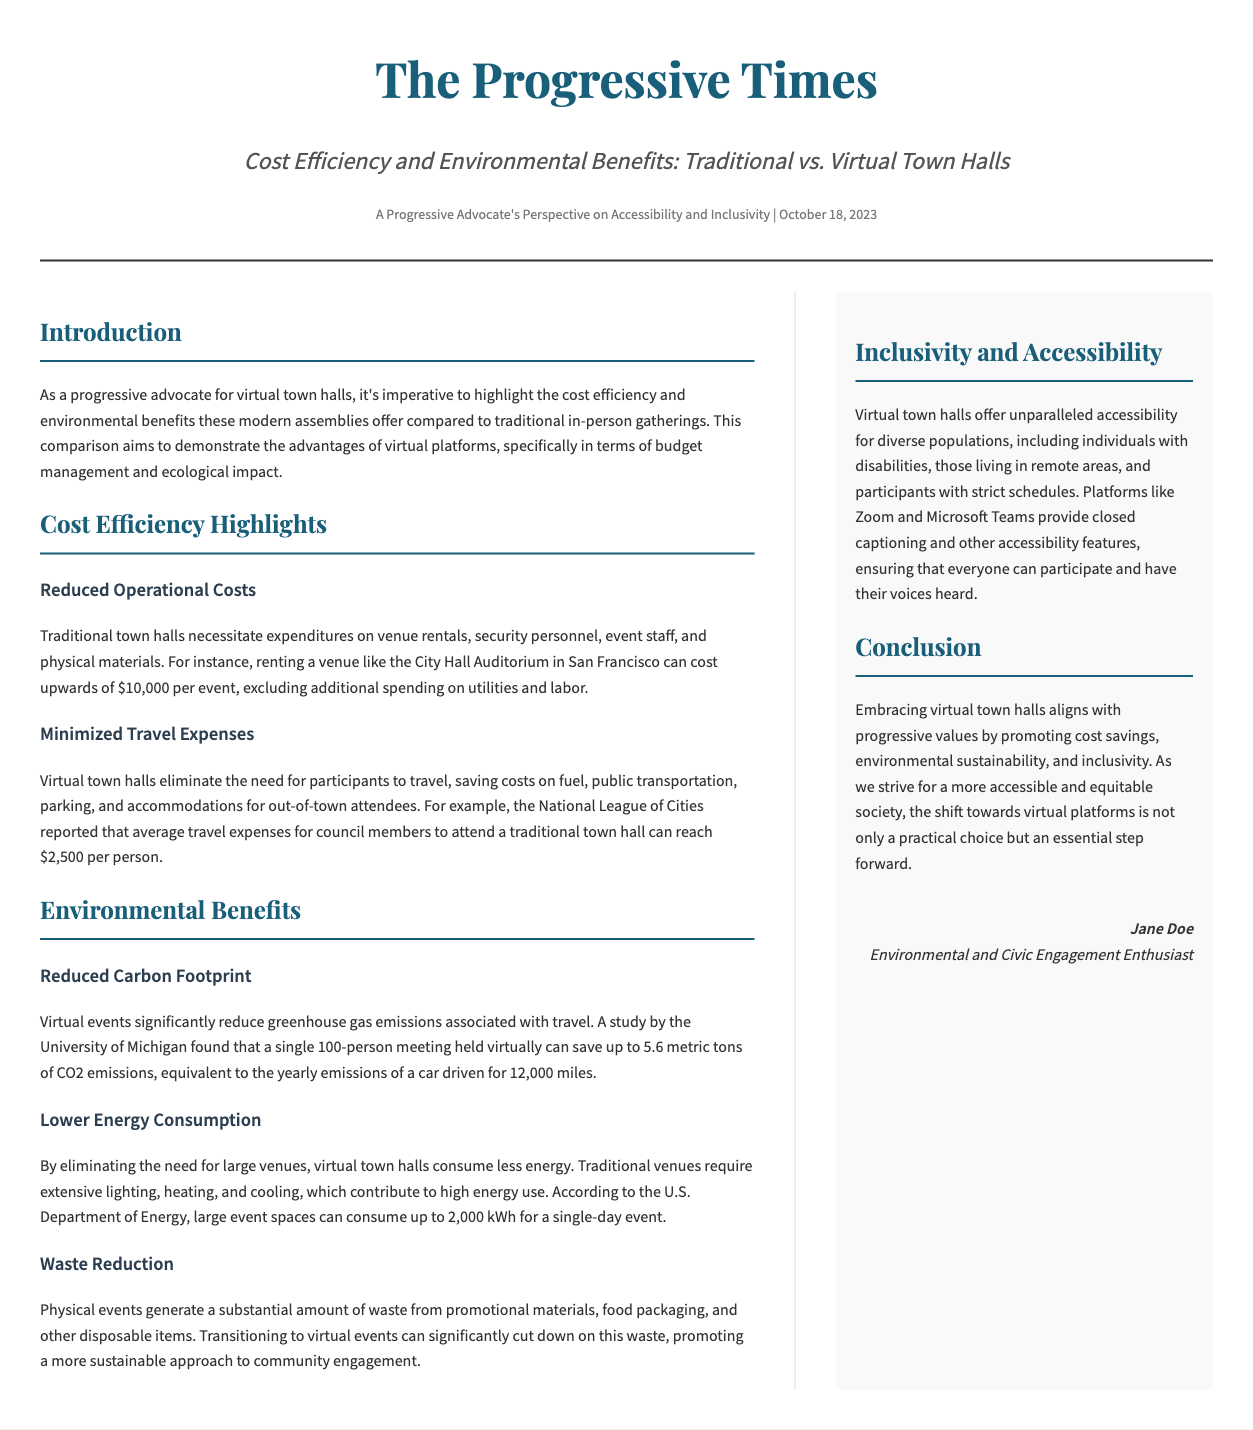what is the subtitle of the article? The subtitle provides insight into the article’s focus, which is "Cost Efficiency and Environmental Benefits: Traditional vs. Virtual Town Halls."
Answer: Cost Efficiency and Environmental Benefits: Traditional vs. Virtual Town Halls how much can renting the City Hall Auditorium cost? The document specifies that renting the venue can cost upwards of $10,000 per event.
Answer: $10,000 what is the average travel expense reported by the National League of Cities? This expense pertains to the cost for council members attending a traditional town hall, reported to be $2,500 per person.
Answer: $2,500 how much CO2 emissions can a virtual 100-person meeting save? The study mentioned indicates that a virtual meeting can save up to 5.6 metric tons of CO2 emissions.
Answer: 5.6 metric tons what is one environmental benefit mentioned in the document? The document outlines several benefits, one of which is the reduction of the carbon footprint from virtual events.
Answer: Reduced carbon footprint what is the significant amount of energy that large event spaces can consume for a single-day event? This figure reflects energy consumption for traditional venues, as stated to be up to 2,000 kWh.
Answer: 2,000 kWh what feature do platforms like Zoom and Microsoft Teams provide? This information highlights the accessibility aspects of virtual town halls, specifically mentioning closed captioning.
Answer: Closed captioning who is the author of the article? The author’s name is provided in the document, identifying them as Jane Doe.
Answer: Jane Doe what is the primary focus of the article? The overall emphasis of the document is compared to traditional town halls, specifically regarding cost efficiency and environmental benefits.
Answer: Cost efficiency and environmental benefits 